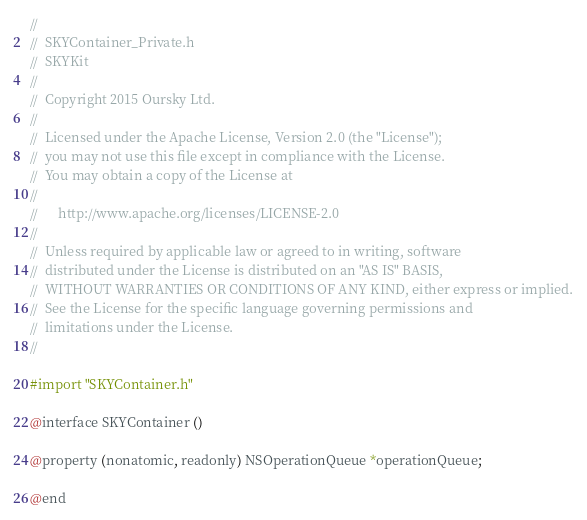Convert code to text. <code><loc_0><loc_0><loc_500><loc_500><_C_>//
//  SKYContainer_Private.h
//  SKYKit
//
//  Copyright 2015 Oursky Ltd.
//
//  Licensed under the Apache License, Version 2.0 (the "License");
//  you may not use this file except in compliance with the License.
//  You may obtain a copy of the License at
//
//      http://www.apache.org/licenses/LICENSE-2.0
//
//  Unless required by applicable law or agreed to in writing, software
//  distributed under the License is distributed on an "AS IS" BASIS,
//  WITHOUT WARRANTIES OR CONDITIONS OF ANY KIND, either express or implied.
//  See the License for the specific language governing permissions and
//  limitations under the License.
//

#import "SKYContainer.h"

@interface SKYContainer ()

@property (nonatomic, readonly) NSOperationQueue *operationQueue;

@end
</code> 